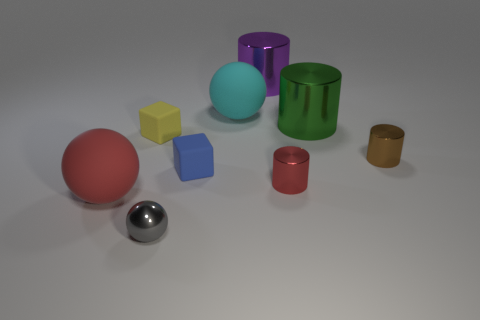Add 1 green objects. How many objects exist? 10 Subtract all cubes. How many objects are left? 7 Add 2 purple things. How many purple things exist? 3 Subtract 0 yellow balls. How many objects are left? 9 Subtract all green shiny cylinders. Subtract all small metallic balls. How many objects are left? 7 Add 4 large purple metallic cylinders. How many large purple metallic cylinders are left? 5 